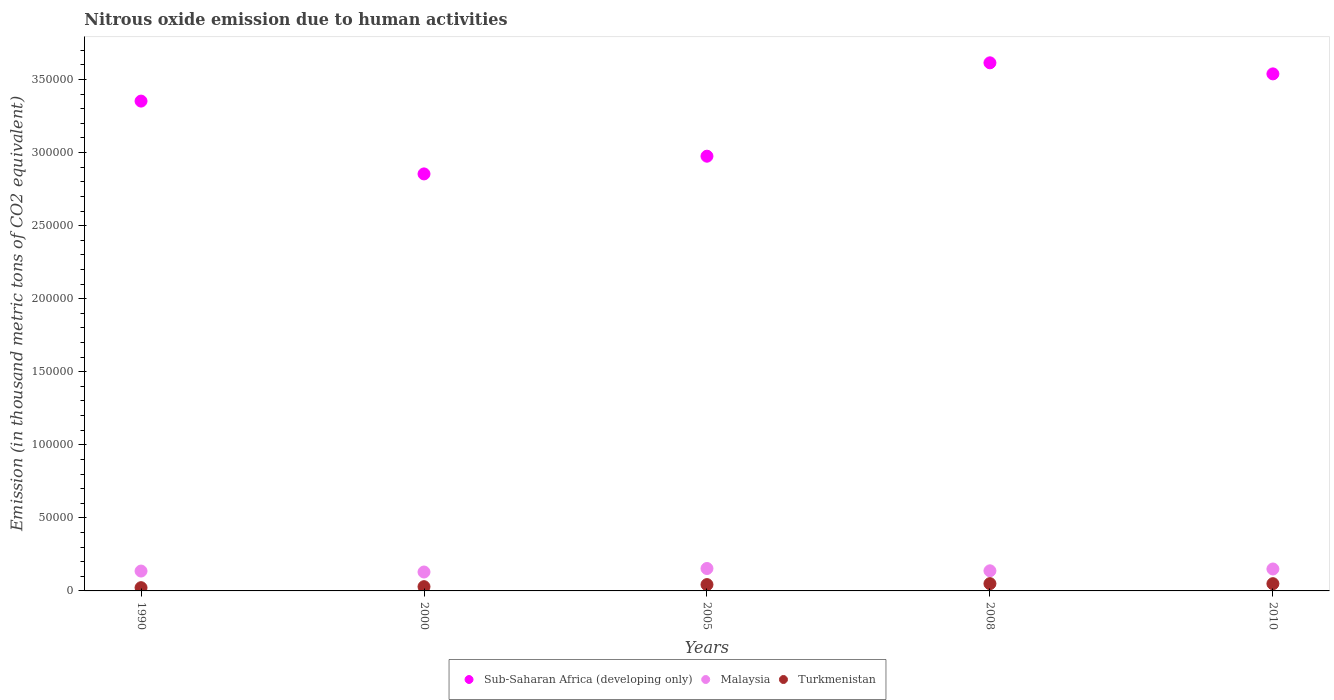What is the amount of nitrous oxide emitted in Turkmenistan in 2000?
Your answer should be very brief. 2907.9. Across all years, what is the maximum amount of nitrous oxide emitted in Sub-Saharan Africa (developing only)?
Your answer should be very brief. 3.61e+05. Across all years, what is the minimum amount of nitrous oxide emitted in Turkmenistan?
Provide a short and direct response. 2225.1. In which year was the amount of nitrous oxide emitted in Turkmenistan minimum?
Give a very brief answer. 1990. What is the total amount of nitrous oxide emitted in Sub-Saharan Africa (developing only) in the graph?
Your response must be concise. 1.63e+06. What is the difference between the amount of nitrous oxide emitted in Malaysia in 1990 and that in 2008?
Your answer should be very brief. -169.4. What is the difference between the amount of nitrous oxide emitted in Malaysia in 1990 and the amount of nitrous oxide emitted in Sub-Saharan Africa (developing only) in 2005?
Your answer should be very brief. -2.84e+05. What is the average amount of nitrous oxide emitted in Malaysia per year?
Provide a short and direct response. 1.41e+04. In the year 2005, what is the difference between the amount of nitrous oxide emitted in Sub-Saharan Africa (developing only) and amount of nitrous oxide emitted in Turkmenistan?
Your response must be concise. 2.93e+05. What is the ratio of the amount of nitrous oxide emitted in Sub-Saharan Africa (developing only) in 2000 to that in 2005?
Your answer should be compact. 0.96. Is the amount of nitrous oxide emitted in Malaysia in 1990 less than that in 2008?
Make the answer very short. Yes. Is the difference between the amount of nitrous oxide emitted in Sub-Saharan Africa (developing only) in 2005 and 2008 greater than the difference between the amount of nitrous oxide emitted in Turkmenistan in 2005 and 2008?
Your answer should be very brief. No. What is the difference between the highest and the second highest amount of nitrous oxide emitted in Turkmenistan?
Provide a succinct answer. 31.9. What is the difference between the highest and the lowest amount of nitrous oxide emitted in Sub-Saharan Africa (developing only)?
Ensure brevity in your answer.  7.60e+04. In how many years, is the amount of nitrous oxide emitted in Turkmenistan greater than the average amount of nitrous oxide emitted in Turkmenistan taken over all years?
Ensure brevity in your answer.  3. Is the sum of the amount of nitrous oxide emitted in Turkmenistan in 1990 and 2005 greater than the maximum amount of nitrous oxide emitted in Malaysia across all years?
Ensure brevity in your answer.  No. Does the amount of nitrous oxide emitted in Turkmenistan monotonically increase over the years?
Ensure brevity in your answer.  No. Is the amount of nitrous oxide emitted in Malaysia strictly less than the amount of nitrous oxide emitted in Sub-Saharan Africa (developing only) over the years?
Offer a terse response. Yes. How many dotlines are there?
Offer a very short reply. 3. Does the graph contain any zero values?
Offer a very short reply. No. Where does the legend appear in the graph?
Ensure brevity in your answer.  Bottom center. How are the legend labels stacked?
Offer a terse response. Horizontal. What is the title of the graph?
Make the answer very short. Nitrous oxide emission due to human activities. What is the label or title of the Y-axis?
Provide a short and direct response. Emission (in thousand metric tons of CO2 equivalent). What is the Emission (in thousand metric tons of CO2 equivalent) in Sub-Saharan Africa (developing only) in 1990?
Make the answer very short. 3.35e+05. What is the Emission (in thousand metric tons of CO2 equivalent) in Malaysia in 1990?
Provide a succinct answer. 1.36e+04. What is the Emission (in thousand metric tons of CO2 equivalent) of Turkmenistan in 1990?
Make the answer very short. 2225.1. What is the Emission (in thousand metric tons of CO2 equivalent) of Sub-Saharan Africa (developing only) in 2000?
Keep it short and to the point. 2.85e+05. What is the Emission (in thousand metric tons of CO2 equivalent) in Malaysia in 2000?
Provide a short and direct response. 1.29e+04. What is the Emission (in thousand metric tons of CO2 equivalent) of Turkmenistan in 2000?
Your response must be concise. 2907.9. What is the Emission (in thousand metric tons of CO2 equivalent) in Sub-Saharan Africa (developing only) in 2005?
Provide a succinct answer. 2.98e+05. What is the Emission (in thousand metric tons of CO2 equivalent) in Malaysia in 2005?
Give a very brief answer. 1.53e+04. What is the Emission (in thousand metric tons of CO2 equivalent) in Turkmenistan in 2005?
Offer a terse response. 4330.6. What is the Emission (in thousand metric tons of CO2 equivalent) of Sub-Saharan Africa (developing only) in 2008?
Offer a very short reply. 3.61e+05. What is the Emission (in thousand metric tons of CO2 equivalent) of Malaysia in 2008?
Offer a very short reply. 1.38e+04. What is the Emission (in thousand metric tons of CO2 equivalent) of Turkmenistan in 2008?
Provide a succinct answer. 4987.1. What is the Emission (in thousand metric tons of CO2 equivalent) in Sub-Saharan Africa (developing only) in 2010?
Offer a terse response. 3.54e+05. What is the Emission (in thousand metric tons of CO2 equivalent) of Malaysia in 2010?
Provide a short and direct response. 1.50e+04. What is the Emission (in thousand metric tons of CO2 equivalent) of Turkmenistan in 2010?
Provide a succinct answer. 4955.2. Across all years, what is the maximum Emission (in thousand metric tons of CO2 equivalent) of Sub-Saharan Africa (developing only)?
Your answer should be compact. 3.61e+05. Across all years, what is the maximum Emission (in thousand metric tons of CO2 equivalent) in Malaysia?
Give a very brief answer. 1.53e+04. Across all years, what is the maximum Emission (in thousand metric tons of CO2 equivalent) in Turkmenistan?
Your answer should be compact. 4987.1. Across all years, what is the minimum Emission (in thousand metric tons of CO2 equivalent) of Sub-Saharan Africa (developing only)?
Your answer should be very brief. 2.85e+05. Across all years, what is the minimum Emission (in thousand metric tons of CO2 equivalent) in Malaysia?
Provide a succinct answer. 1.29e+04. Across all years, what is the minimum Emission (in thousand metric tons of CO2 equivalent) of Turkmenistan?
Make the answer very short. 2225.1. What is the total Emission (in thousand metric tons of CO2 equivalent) of Sub-Saharan Africa (developing only) in the graph?
Offer a very short reply. 1.63e+06. What is the total Emission (in thousand metric tons of CO2 equivalent) in Malaysia in the graph?
Your response must be concise. 7.07e+04. What is the total Emission (in thousand metric tons of CO2 equivalent) in Turkmenistan in the graph?
Ensure brevity in your answer.  1.94e+04. What is the difference between the Emission (in thousand metric tons of CO2 equivalent) in Sub-Saharan Africa (developing only) in 1990 and that in 2000?
Give a very brief answer. 4.98e+04. What is the difference between the Emission (in thousand metric tons of CO2 equivalent) in Malaysia in 1990 and that in 2000?
Keep it short and to the point. 651.9. What is the difference between the Emission (in thousand metric tons of CO2 equivalent) in Turkmenistan in 1990 and that in 2000?
Give a very brief answer. -682.8. What is the difference between the Emission (in thousand metric tons of CO2 equivalent) in Sub-Saharan Africa (developing only) in 1990 and that in 2005?
Make the answer very short. 3.77e+04. What is the difference between the Emission (in thousand metric tons of CO2 equivalent) of Malaysia in 1990 and that in 2005?
Provide a succinct answer. -1747.4. What is the difference between the Emission (in thousand metric tons of CO2 equivalent) in Turkmenistan in 1990 and that in 2005?
Make the answer very short. -2105.5. What is the difference between the Emission (in thousand metric tons of CO2 equivalent) in Sub-Saharan Africa (developing only) in 1990 and that in 2008?
Ensure brevity in your answer.  -2.62e+04. What is the difference between the Emission (in thousand metric tons of CO2 equivalent) in Malaysia in 1990 and that in 2008?
Offer a terse response. -169.4. What is the difference between the Emission (in thousand metric tons of CO2 equivalent) of Turkmenistan in 1990 and that in 2008?
Your answer should be compact. -2762. What is the difference between the Emission (in thousand metric tons of CO2 equivalent) in Sub-Saharan Africa (developing only) in 1990 and that in 2010?
Make the answer very short. -1.86e+04. What is the difference between the Emission (in thousand metric tons of CO2 equivalent) of Malaysia in 1990 and that in 2010?
Offer a very short reply. -1413.8. What is the difference between the Emission (in thousand metric tons of CO2 equivalent) of Turkmenistan in 1990 and that in 2010?
Ensure brevity in your answer.  -2730.1. What is the difference between the Emission (in thousand metric tons of CO2 equivalent) of Sub-Saharan Africa (developing only) in 2000 and that in 2005?
Offer a terse response. -1.21e+04. What is the difference between the Emission (in thousand metric tons of CO2 equivalent) of Malaysia in 2000 and that in 2005?
Your answer should be very brief. -2399.3. What is the difference between the Emission (in thousand metric tons of CO2 equivalent) in Turkmenistan in 2000 and that in 2005?
Give a very brief answer. -1422.7. What is the difference between the Emission (in thousand metric tons of CO2 equivalent) of Sub-Saharan Africa (developing only) in 2000 and that in 2008?
Offer a very short reply. -7.60e+04. What is the difference between the Emission (in thousand metric tons of CO2 equivalent) of Malaysia in 2000 and that in 2008?
Offer a terse response. -821.3. What is the difference between the Emission (in thousand metric tons of CO2 equivalent) of Turkmenistan in 2000 and that in 2008?
Give a very brief answer. -2079.2. What is the difference between the Emission (in thousand metric tons of CO2 equivalent) of Sub-Saharan Africa (developing only) in 2000 and that in 2010?
Your response must be concise. -6.85e+04. What is the difference between the Emission (in thousand metric tons of CO2 equivalent) of Malaysia in 2000 and that in 2010?
Your response must be concise. -2065.7. What is the difference between the Emission (in thousand metric tons of CO2 equivalent) of Turkmenistan in 2000 and that in 2010?
Ensure brevity in your answer.  -2047.3. What is the difference between the Emission (in thousand metric tons of CO2 equivalent) in Sub-Saharan Africa (developing only) in 2005 and that in 2008?
Give a very brief answer. -6.39e+04. What is the difference between the Emission (in thousand metric tons of CO2 equivalent) in Malaysia in 2005 and that in 2008?
Offer a very short reply. 1578. What is the difference between the Emission (in thousand metric tons of CO2 equivalent) of Turkmenistan in 2005 and that in 2008?
Make the answer very short. -656.5. What is the difference between the Emission (in thousand metric tons of CO2 equivalent) in Sub-Saharan Africa (developing only) in 2005 and that in 2010?
Your answer should be very brief. -5.63e+04. What is the difference between the Emission (in thousand metric tons of CO2 equivalent) of Malaysia in 2005 and that in 2010?
Your response must be concise. 333.6. What is the difference between the Emission (in thousand metric tons of CO2 equivalent) of Turkmenistan in 2005 and that in 2010?
Your response must be concise. -624.6. What is the difference between the Emission (in thousand metric tons of CO2 equivalent) of Sub-Saharan Africa (developing only) in 2008 and that in 2010?
Provide a succinct answer. 7568.3. What is the difference between the Emission (in thousand metric tons of CO2 equivalent) of Malaysia in 2008 and that in 2010?
Keep it short and to the point. -1244.4. What is the difference between the Emission (in thousand metric tons of CO2 equivalent) in Turkmenistan in 2008 and that in 2010?
Offer a terse response. 31.9. What is the difference between the Emission (in thousand metric tons of CO2 equivalent) in Sub-Saharan Africa (developing only) in 1990 and the Emission (in thousand metric tons of CO2 equivalent) in Malaysia in 2000?
Make the answer very short. 3.22e+05. What is the difference between the Emission (in thousand metric tons of CO2 equivalent) of Sub-Saharan Africa (developing only) in 1990 and the Emission (in thousand metric tons of CO2 equivalent) of Turkmenistan in 2000?
Your answer should be very brief. 3.32e+05. What is the difference between the Emission (in thousand metric tons of CO2 equivalent) of Malaysia in 1990 and the Emission (in thousand metric tons of CO2 equivalent) of Turkmenistan in 2000?
Make the answer very short. 1.07e+04. What is the difference between the Emission (in thousand metric tons of CO2 equivalent) of Sub-Saharan Africa (developing only) in 1990 and the Emission (in thousand metric tons of CO2 equivalent) of Malaysia in 2005?
Make the answer very short. 3.20e+05. What is the difference between the Emission (in thousand metric tons of CO2 equivalent) of Sub-Saharan Africa (developing only) in 1990 and the Emission (in thousand metric tons of CO2 equivalent) of Turkmenistan in 2005?
Your answer should be compact. 3.31e+05. What is the difference between the Emission (in thousand metric tons of CO2 equivalent) of Malaysia in 1990 and the Emission (in thousand metric tons of CO2 equivalent) of Turkmenistan in 2005?
Your answer should be compact. 9265.6. What is the difference between the Emission (in thousand metric tons of CO2 equivalent) of Sub-Saharan Africa (developing only) in 1990 and the Emission (in thousand metric tons of CO2 equivalent) of Malaysia in 2008?
Offer a very short reply. 3.21e+05. What is the difference between the Emission (in thousand metric tons of CO2 equivalent) in Sub-Saharan Africa (developing only) in 1990 and the Emission (in thousand metric tons of CO2 equivalent) in Turkmenistan in 2008?
Give a very brief answer. 3.30e+05. What is the difference between the Emission (in thousand metric tons of CO2 equivalent) in Malaysia in 1990 and the Emission (in thousand metric tons of CO2 equivalent) in Turkmenistan in 2008?
Your response must be concise. 8609.1. What is the difference between the Emission (in thousand metric tons of CO2 equivalent) of Sub-Saharan Africa (developing only) in 1990 and the Emission (in thousand metric tons of CO2 equivalent) of Malaysia in 2010?
Keep it short and to the point. 3.20e+05. What is the difference between the Emission (in thousand metric tons of CO2 equivalent) in Sub-Saharan Africa (developing only) in 1990 and the Emission (in thousand metric tons of CO2 equivalent) in Turkmenistan in 2010?
Provide a short and direct response. 3.30e+05. What is the difference between the Emission (in thousand metric tons of CO2 equivalent) of Malaysia in 1990 and the Emission (in thousand metric tons of CO2 equivalent) of Turkmenistan in 2010?
Make the answer very short. 8641. What is the difference between the Emission (in thousand metric tons of CO2 equivalent) of Sub-Saharan Africa (developing only) in 2000 and the Emission (in thousand metric tons of CO2 equivalent) of Malaysia in 2005?
Give a very brief answer. 2.70e+05. What is the difference between the Emission (in thousand metric tons of CO2 equivalent) in Sub-Saharan Africa (developing only) in 2000 and the Emission (in thousand metric tons of CO2 equivalent) in Turkmenistan in 2005?
Provide a short and direct response. 2.81e+05. What is the difference between the Emission (in thousand metric tons of CO2 equivalent) in Malaysia in 2000 and the Emission (in thousand metric tons of CO2 equivalent) in Turkmenistan in 2005?
Give a very brief answer. 8613.7. What is the difference between the Emission (in thousand metric tons of CO2 equivalent) in Sub-Saharan Africa (developing only) in 2000 and the Emission (in thousand metric tons of CO2 equivalent) in Malaysia in 2008?
Offer a terse response. 2.72e+05. What is the difference between the Emission (in thousand metric tons of CO2 equivalent) in Sub-Saharan Africa (developing only) in 2000 and the Emission (in thousand metric tons of CO2 equivalent) in Turkmenistan in 2008?
Ensure brevity in your answer.  2.80e+05. What is the difference between the Emission (in thousand metric tons of CO2 equivalent) of Malaysia in 2000 and the Emission (in thousand metric tons of CO2 equivalent) of Turkmenistan in 2008?
Your response must be concise. 7957.2. What is the difference between the Emission (in thousand metric tons of CO2 equivalent) of Sub-Saharan Africa (developing only) in 2000 and the Emission (in thousand metric tons of CO2 equivalent) of Malaysia in 2010?
Offer a very short reply. 2.70e+05. What is the difference between the Emission (in thousand metric tons of CO2 equivalent) of Sub-Saharan Africa (developing only) in 2000 and the Emission (in thousand metric tons of CO2 equivalent) of Turkmenistan in 2010?
Provide a succinct answer. 2.80e+05. What is the difference between the Emission (in thousand metric tons of CO2 equivalent) of Malaysia in 2000 and the Emission (in thousand metric tons of CO2 equivalent) of Turkmenistan in 2010?
Provide a short and direct response. 7989.1. What is the difference between the Emission (in thousand metric tons of CO2 equivalent) in Sub-Saharan Africa (developing only) in 2005 and the Emission (in thousand metric tons of CO2 equivalent) in Malaysia in 2008?
Offer a terse response. 2.84e+05. What is the difference between the Emission (in thousand metric tons of CO2 equivalent) of Sub-Saharan Africa (developing only) in 2005 and the Emission (in thousand metric tons of CO2 equivalent) of Turkmenistan in 2008?
Ensure brevity in your answer.  2.93e+05. What is the difference between the Emission (in thousand metric tons of CO2 equivalent) in Malaysia in 2005 and the Emission (in thousand metric tons of CO2 equivalent) in Turkmenistan in 2008?
Provide a short and direct response. 1.04e+04. What is the difference between the Emission (in thousand metric tons of CO2 equivalent) of Sub-Saharan Africa (developing only) in 2005 and the Emission (in thousand metric tons of CO2 equivalent) of Malaysia in 2010?
Make the answer very short. 2.83e+05. What is the difference between the Emission (in thousand metric tons of CO2 equivalent) in Sub-Saharan Africa (developing only) in 2005 and the Emission (in thousand metric tons of CO2 equivalent) in Turkmenistan in 2010?
Your response must be concise. 2.93e+05. What is the difference between the Emission (in thousand metric tons of CO2 equivalent) of Malaysia in 2005 and the Emission (in thousand metric tons of CO2 equivalent) of Turkmenistan in 2010?
Your response must be concise. 1.04e+04. What is the difference between the Emission (in thousand metric tons of CO2 equivalent) of Sub-Saharan Africa (developing only) in 2008 and the Emission (in thousand metric tons of CO2 equivalent) of Malaysia in 2010?
Provide a succinct answer. 3.46e+05. What is the difference between the Emission (in thousand metric tons of CO2 equivalent) of Sub-Saharan Africa (developing only) in 2008 and the Emission (in thousand metric tons of CO2 equivalent) of Turkmenistan in 2010?
Make the answer very short. 3.57e+05. What is the difference between the Emission (in thousand metric tons of CO2 equivalent) in Malaysia in 2008 and the Emission (in thousand metric tons of CO2 equivalent) in Turkmenistan in 2010?
Keep it short and to the point. 8810.4. What is the average Emission (in thousand metric tons of CO2 equivalent) in Sub-Saharan Africa (developing only) per year?
Keep it short and to the point. 3.27e+05. What is the average Emission (in thousand metric tons of CO2 equivalent) of Malaysia per year?
Provide a succinct answer. 1.41e+04. What is the average Emission (in thousand metric tons of CO2 equivalent) of Turkmenistan per year?
Your answer should be compact. 3881.18. In the year 1990, what is the difference between the Emission (in thousand metric tons of CO2 equivalent) in Sub-Saharan Africa (developing only) and Emission (in thousand metric tons of CO2 equivalent) in Malaysia?
Give a very brief answer. 3.22e+05. In the year 1990, what is the difference between the Emission (in thousand metric tons of CO2 equivalent) of Sub-Saharan Africa (developing only) and Emission (in thousand metric tons of CO2 equivalent) of Turkmenistan?
Provide a succinct answer. 3.33e+05. In the year 1990, what is the difference between the Emission (in thousand metric tons of CO2 equivalent) in Malaysia and Emission (in thousand metric tons of CO2 equivalent) in Turkmenistan?
Offer a very short reply. 1.14e+04. In the year 2000, what is the difference between the Emission (in thousand metric tons of CO2 equivalent) in Sub-Saharan Africa (developing only) and Emission (in thousand metric tons of CO2 equivalent) in Malaysia?
Ensure brevity in your answer.  2.72e+05. In the year 2000, what is the difference between the Emission (in thousand metric tons of CO2 equivalent) in Sub-Saharan Africa (developing only) and Emission (in thousand metric tons of CO2 equivalent) in Turkmenistan?
Your answer should be very brief. 2.83e+05. In the year 2000, what is the difference between the Emission (in thousand metric tons of CO2 equivalent) in Malaysia and Emission (in thousand metric tons of CO2 equivalent) in Turkmenistan?
Your answer should be compact. 1.00e+04. In the year 2005, what is the difference between the Emission (in thousand metric tons of CO2 equivalent) of Sub-Saharan Africa (developing only) and Emission (in thousand metric tons of CO2 equivalent) of Malaysia?
Ensure brevity in your answer.  2.82e+05. In the year 2005, what is the difference between the Emission (in thousand metric tons of CO2 equivalent) in Sub-Saharan Africa (developing only) and Emission (in thousand metric tons of CO2 equivalent) in Turkmenistan?
Provide a short and direct response. 2.93e+05. In the year 2005, what is the difference between the Emission (in thousand metric tons of CO2 equivalent) in Malaysia and Emission (in thousand metric tons of CO2 equivalent) in Turkmenistan?
Provide a succinct answer. 1.10e+04. In the year 2008, what is the difference between the Emission (in thousand metric tons of CO2 equivalent) in Sub-Saharan Africa (developing only) and Emission (in thousand metric tons of CO2 equivalent) in Malaysia?
Offer a very short reply. 3.48e+05. In the year 2008, what is the difference between the Emission (in thousand metric tons of CO2 equivalent) of Sub-Saharan Africa (developing only) and Emission (in thousand metric tons of CO2 equivalent) of Turkmenistan?
Give a very brief answer. 3.56e+05. In the year 2008, what is the difference between the Emission (in thousand metric tons of CO2 equivalent) of Malaysia and Emission (in thousand metric tons of CO2 equivalent) of Turkmenistan?
Give a very brief answer. 8778.5. In the year 2010, what is the difference between the Emission (in thousand metric tons of CO2 equivalent) of Sub-Saharan Africa (developing only) and Emission (in thousand metric tons of CO2 equivalent) of Malaysia?
Keep it short and to the point. 3.39e+05. In the year 2010, what is the difference between the Emission (in thousand metric tons of CO2 equivalent) in Sub-Saharan Africa (developing only) and Emission (in thousand metric tons of CO2 equivalent) in Turkmenistan?
Your response must be concise. 3.49e+05. In the year 2010, what is the difference between the Emission (in thousand metric tons of CO2 equivalent) in Malaysia and Emission (in thousand metric tons of CO2 equivalent) in Turkmenistan?
Keep it short and to the point. 1.01e+04. What is the ratio of the Emission (in thousand metric tons of CO2 equivalent) of Sub-Saharan Africa (developing only) in 1990 to that in 2000?
Make the answer very short. 1.17. What is the ratio of the Emission (in thousand metric tons of CO2 equivalent) of Malaysia in 1990 to that in 2000?
Keep it short and to the point. 1.05. What is the ratio of the Emission (in thousand metric tons of CO2 equivalent) in Turkmenistan in 1990 to that in 2000?
Keep it short and to the point. 0.77. What is the ratio of the Emission (in thousand metric tons of CO2 equivalent) in Sub-Saharan Africa (developing only) in 1990 to that in 2005?
Make the answer very short. 1.13. What is the ratio of the Emission (in thousand metric tons of CO2 equivalent) in Malaysia in 1990 to that in 2005?
Your response must be concise. 0.89. What is the ratio of the Emission (in thousand metric tons of CO2 equivalent) of Turkmenistan in 1990 to that in 2005?
Give a very brief answer. 0.51. What is the ratio of the Emission (in thousand metric tons of CO2 equivalent) of Sub-Saharan Africa (developing only) in 1990 to that in 2008?
Give a very brief answer. 0.93. What is the ratio of the Emission (in thousand metric tons of CO2 equivalent) in Turkmenistan in 1990 to that in 2008?
Your answer should be very brief. 0.45. What is the ratio of the Emission (in thousand metric tons of CO2 equivalent) in Sub-Saharan Africa (developing only) in 1990 to that in 2010?
Give a very brief answer. 0.95. What is the ratio of the Emission (in thousand metric tons of CO2 equivalent) of Malaysia in 1990 to that in 2010?
Offer a terse response. 0.91. What is the ratio of the Emission (in thousand metric tons of CO2 equivalent) of Turkmenistan in 1990 to that in 2010?
Keep it short and to the point. 0.45. What is the ratio of the Emission (in thousand metric tons of CO2 equivalent) in Sub-Saharan Africa (developing only) in 2000 to that in 2005?
Keep it short and to the point. 0.96. What is the ratio of the Emission (in thousand metric tons of CO2 equivalent) of Malaysia in 2000 to that in 2005?
Provide a succinct answer. 0.84. What is the ratio of the Emission (in thousand metric tons of CO2 equivalent) in Turkmenistan in 2000 to that in 2005?
Make the answer very short. 0.67. What is the ratio of the Emission (in thousand metric tons of CO2 equivalent) of Sub-Saharan Africa (developing only) in 2000 to that in 2008?
Your answer should be compact. 0.79. What is the ratio of the Emission (in thousand metric tons of CO2 equivalent) in Malaysia in 2000 to that in 2008?
Ensure brevity in your answer.  0.94. What is the ratio of the Emission (in thousand metric tons of CO2 equivalent) of Turkmenistan in 2000 to that in 2008?
Provide a succinct answer. 0.58. What is the ratio of the Emission (in thousand metric tons of CO2 equivalent) in Sub-Saharan Africa (developing only) in 2000 to that in 2010?
Your answer should be compact. 0.81. What is the ratio of the Emission (in thousand metric tons of CO2 equivalent) in Malaysia in 2000 to that in 2010?
Your answer should be very brief. 0.86. What is the ratio of the Emission (in thousand metric tons of CO2 equivalent) of Turkmenistan in 2000 to that in 2010?
Offer a terse response. 0.59. What is the ratio of the Emission (in thousand metric tons of CO2 equivalent) of Sub-Saharan Africa (developing only) in 2005 to that in 2008?
Your answer should be very brief. 0.82. What is the ratio of the Emission (in thousand metric tons of CO2 equivalent) in Malaysia in 2005 to that in 2008?
Ensure brevity in your answer.  1.11. What is the ratio of the Emission (in thousand metric tons of CO2 equivalent) in Turkmenistan in 2005 to that in 2008?
Offer a terse response. 0.87. What is the ratio of the Emission (in thousand metric tons of CO2 equivalent) in Sub-Saharan Africa (developing only) in 2005 to that in 2010?
Offer a very short reply. 0.84. What is the ratio of the Emission (in thousand metric tons of CO2 equivalent) in Malaysia in 2005 to that in 2010?
Give a very brief answer. 1.02. What is the ratio of the Emission (in thousand metric tons of CO2 equivalent) of Turkmenistan in 2005 to that in 2010?
Your answer should be compact. 0.87. What is the ratio of the Emission (in thousand metric tons of CO2 equivalent) of Sub-Saharan Africa (developing only) in 2008 to that in 2010?
Your answer should be very brief. 1.02. What is the ratio of the Emission (in thousand metric tons of CO2 equivalent) in Malaysia in 2008 to that in 2010?
Provide a succinct answer. 0.92. What is the ratio of the Emission (in thousand metric tons of CO2 equivalent) of Turkmenistan in 2008 to that in 2010?
Give a very brief answer. 1.01. What is the difference between the highest and the second highest Emission (in thousand metric tons of CO2 equivalent) of Sub-Saharan Africa (developing only)?
Offer a very short reply. 7568.3. What is the difference between the highest and the second highest Emission (in thousand metric tons of CO2 equivalent) in Malaysia?
Ensure brevity in your answer.  333.6. What is the difference between the highest and the second highest Emission (in thousand metric tons of CO2 equivalent) of Turkmenistan?
Offer a very short reply. 31.9. What is the difference between the highest and the lowest Emission (in thousand metric tons of CO2 equivalent) in Sub-Saharan Africa (developing only)?
Give a very brief answer. 7.60e+04. What is the difference between the highest and the lowest Emission (in thousand metric tons of CO2 equivalent) of Malaysia?
Offer a very short reply. 2399.3. What is the difference between the highest and the lowest Emission (in thousand metric tons of CO2 equivalent) of Turkmenistan?
Give a very brief answer. 2762. 